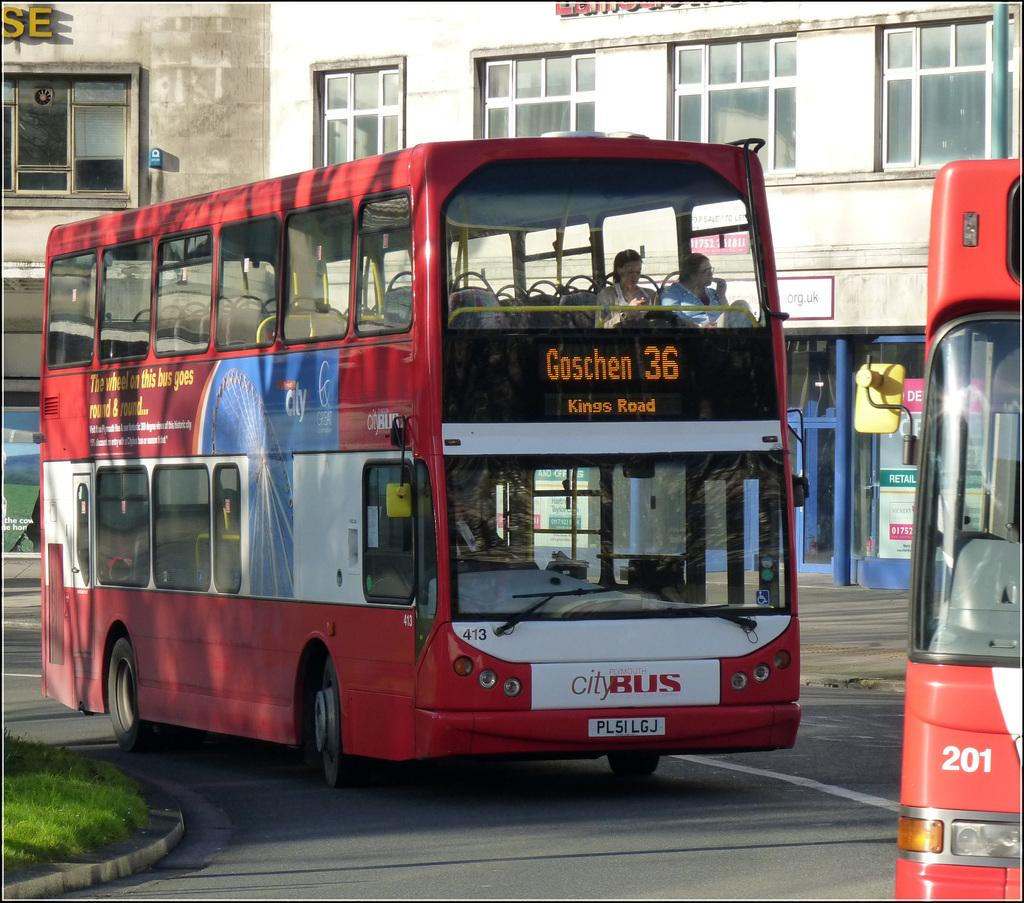What type of vehicles are on the road in the image? There are two buses on the road in the image. Are there any passengers visible inside the buses? Yes, there are two people sitting inside one of the buses. What can be seen beside the buses? There is grass visible beside the buses. What is visible in the background of the image? There is a building in the background. How many fish can be seen swimming in the grass beside the buses? There are no fish visible in the image; it features buses on the road with grass beside them. What color is the silver mice in the background of the image? There are no mice, silver or otherwise, present in the image. 